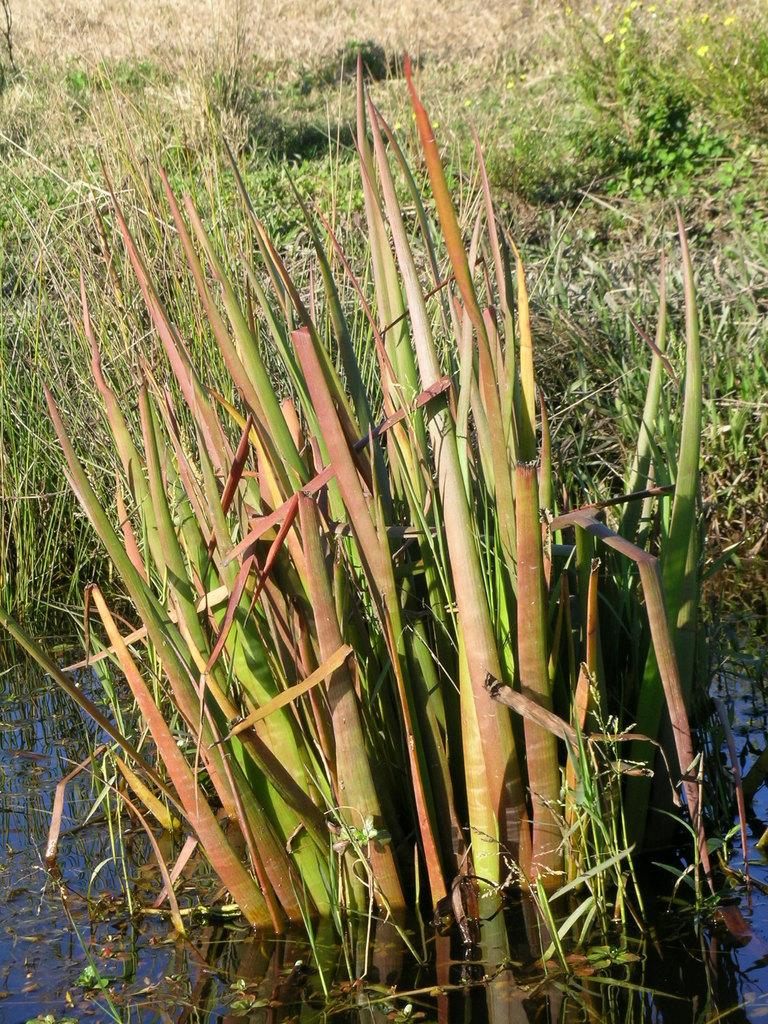What is the main subject of the image? The main subject of the image is a grass plant in the water. Are there any other plants visible in the image? Yes, there is a grass with some plants beside the grass plant in the water. Can you see a cow grazing on the grass in the image? No, there is no cow present in the image. What type of rock can be seen supporting the grass plant in the image? There is no rock visible in the image; the grass plant is in the water. 